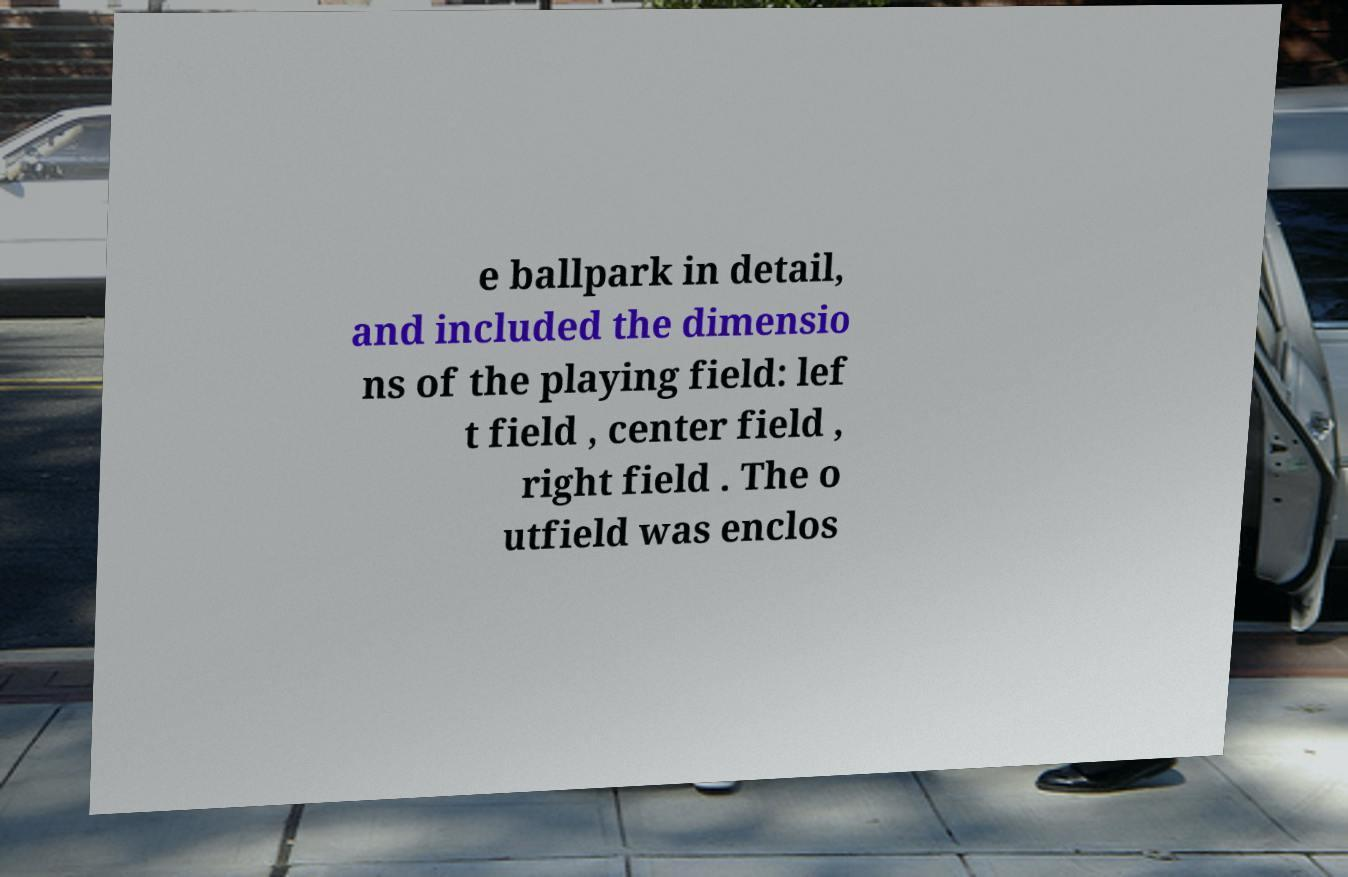There's text embedded in this image that I need extracted. Can you transcribe it verbatim? e ballpark in detail, and included the dimensio ns of the playing field: lef t field , center field , right field . The o utfield was enclos 